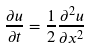Convert formula to latex. <formula><loc_0><loc_0><loc_500><loc_500>\frac { \partial u } { \partial t } = \frac { 1 } { 2 } \frac { \partial ^ { 2 } u } { \partial x ^ { 2 } }</formula> 